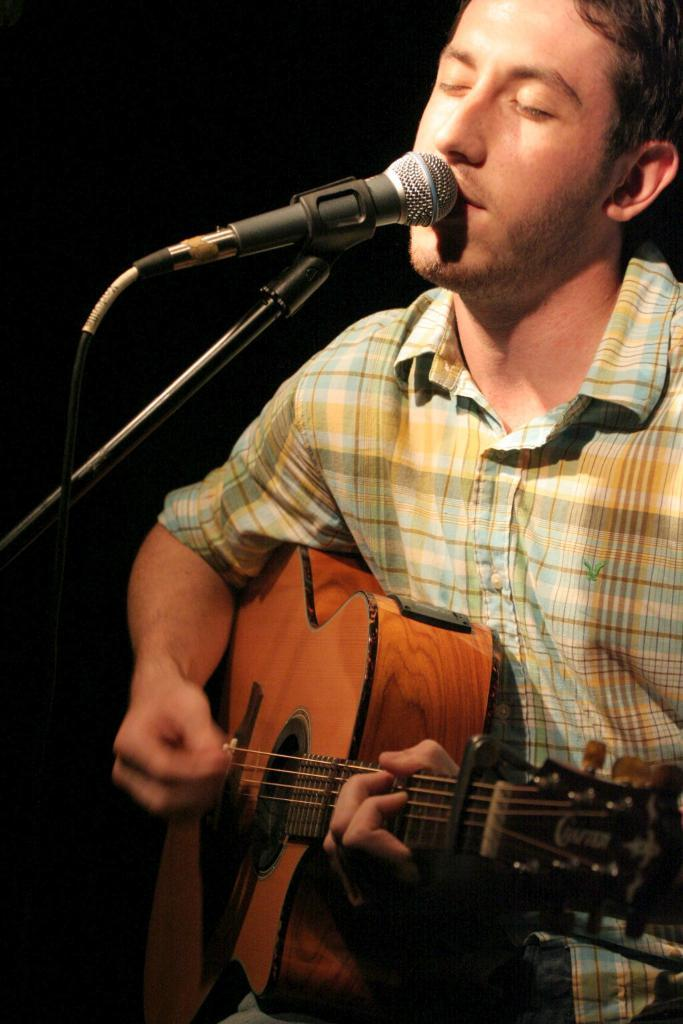What is the man in the image doing? The man is singing in the image. What tool is the man using while singing? The man is using a microphone. What musical instrument is the man playing? The man is playing a guitar. What type of plant is the man using as a cover while singing? There is no plant present in the image, and the man is not using any cover while singing. 